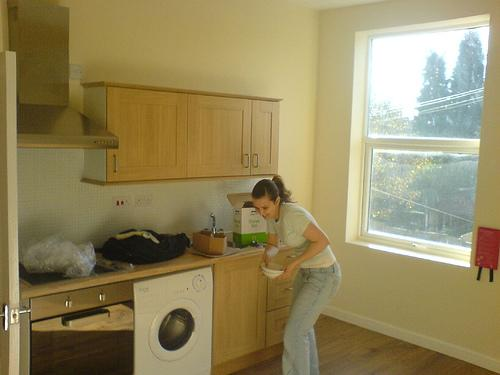What is the woman using the bowl for here?

Choices:
A) hidden camera
B) feeding baby
C) feed pet
D) trapping rats feed pet 